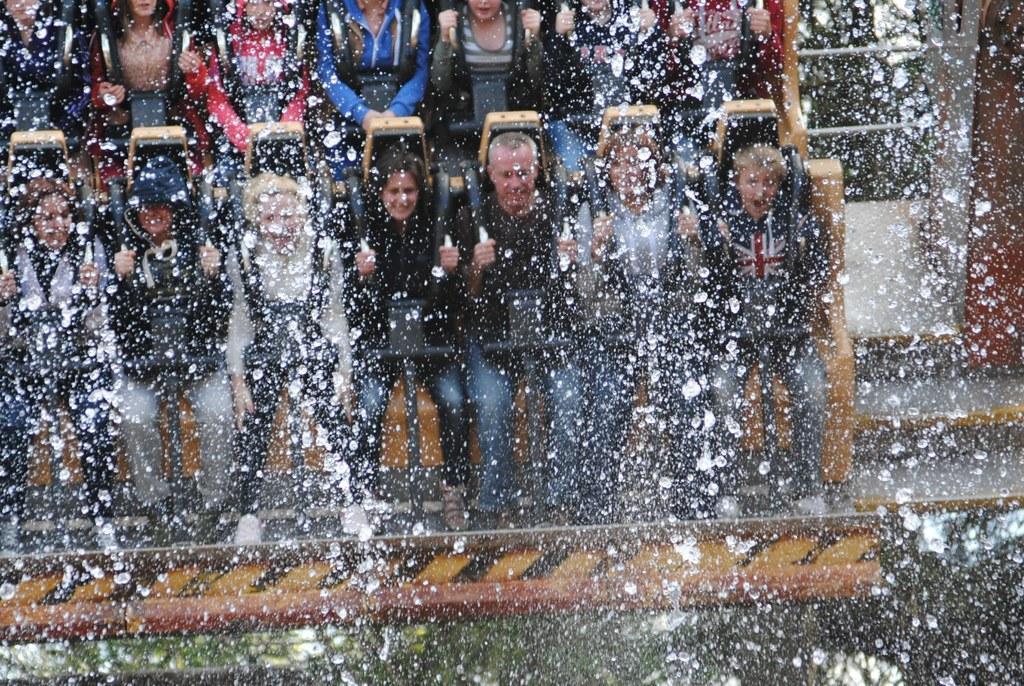How would you summarize this image in a sentence or two? In the image it looks like there are many people taking some water ride. 